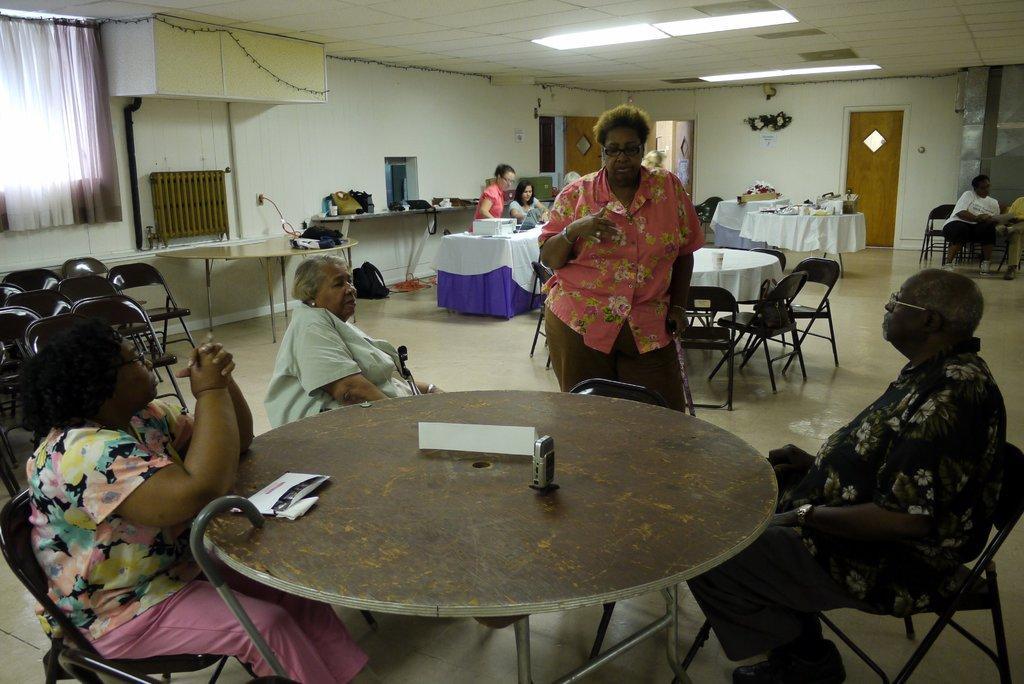How would you summarize this image in a sentence or two? This picture is clicked inside the room. Here, we see three people sitting on the chair and woman in pink shirt is explaining them something and in front of them, we see a table on which paper and mobile phone are placed and behind her, we see many chairs and tables and on the top of the picture, we see the ceiling of that room. 